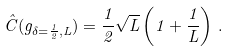Convert formula to latex. <formula><loc_0><loc_0><loc_500><loc_500>\hat { C } ( g _ { \delta = \frac { 1 } { 2 } , L } ) = \frac { 1 } { 2 } \sqrt { L } \left ( 1 + \frac { 1 } { L } \right ) \, .</formula> 